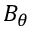Convert formula to latex. <formula><loc_0><loc_0><loc_500><loc_500>B _ { \theta }</formula> 